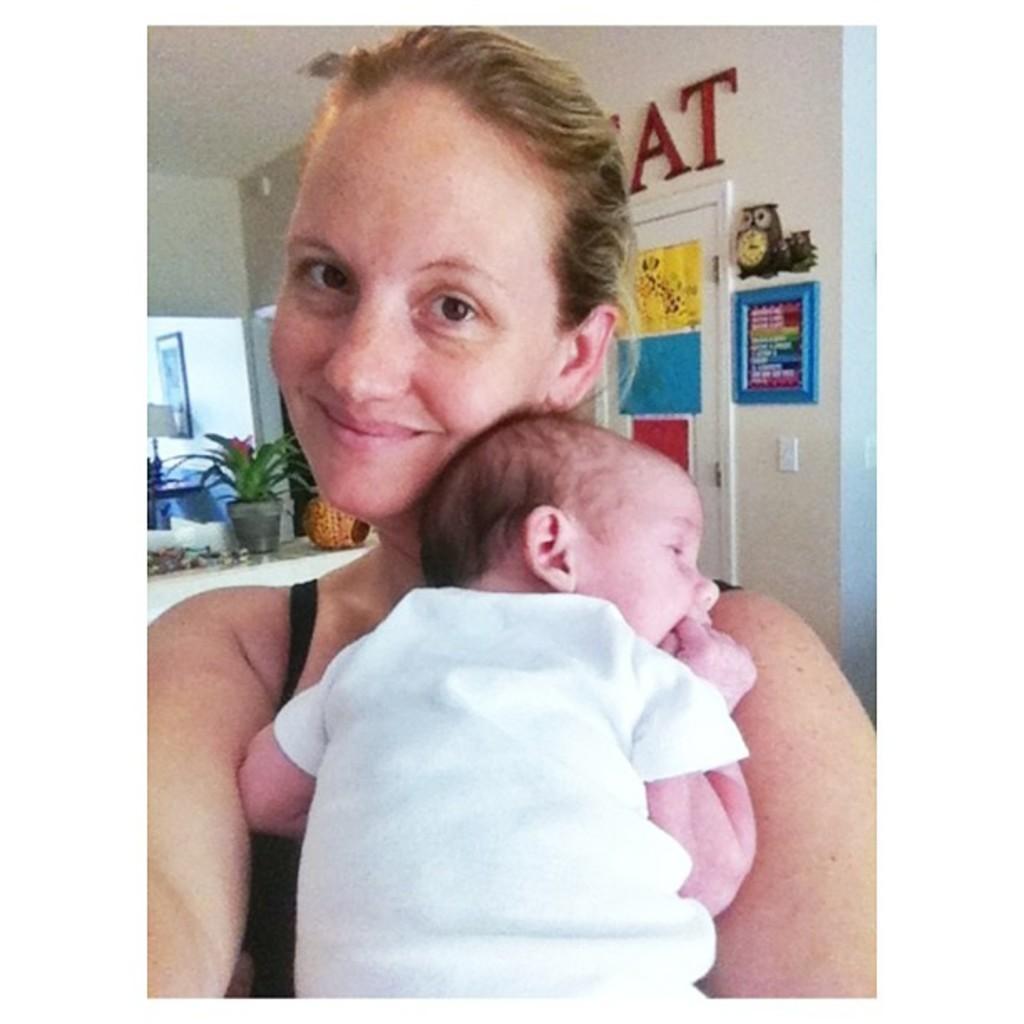Describe this image in one or two sentences. In this picture we can see a woman, baby, she is smiling and in the background we can see a wall, house plant, photo frame, lamp, posters, door and some objects. 